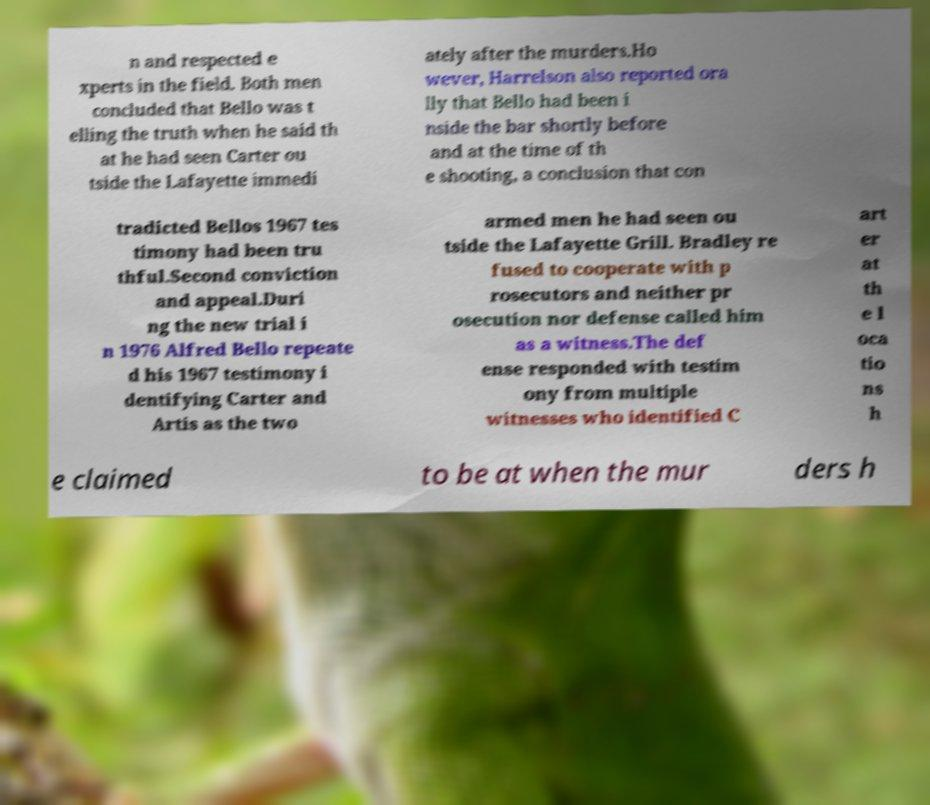Can you read and provide the text displayed in the image?This photo seems to have some interesting text. Can you extract and type it out for me? n and respected e xperts in the field. Both men concluded that Bello was t elling the truth when he said th at he had seen Carter ou tside the Lafayette immedi ately after the murders.Ho wever, Harrelson also reported ora lly that Bello had been i nside the bar shortly before and at the time of th e shooting, a conclusion that con tradicted Bellos 1967 tes timony had been tru thful.Second conviction and appeal.Duri ng the new trial i n 1976 Alfred Bello repeate d his 1967 testimony i dentifying Carter and Artis as the two armed men he had seen ou tside the Lafayette Grill. Bradley re fused to cooperate with p rosecutors and neither pr osecution nor defense called him as a witness.The def ense responded with testim ony from multiple witnesses who identified C art er at th e l oca tio ns h e claimed to be at when the mur ders h 